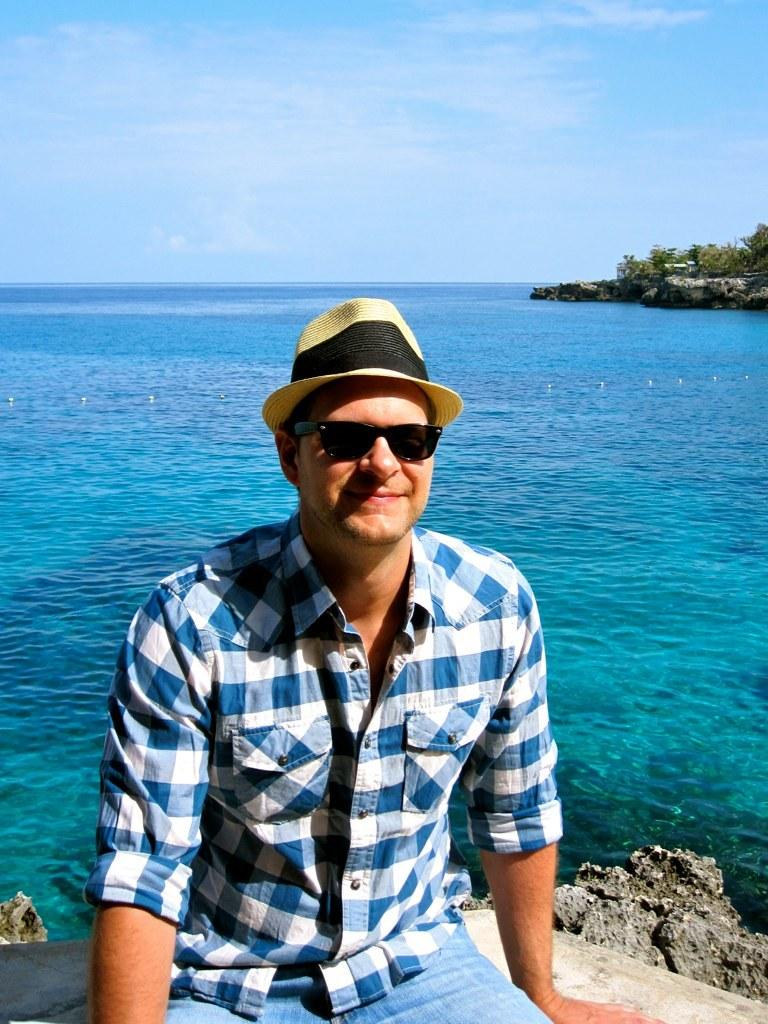What can be seen in the image? There is a person in the image. What is the person wearing? The person is wearing goggles and a hat. What is the person's facial expression? The person is smiling. What is the person's position in the image? The person is sitting on a surface. What can be seen in the background of the image? There is a wall, trees, rocks, water, and the sky visible in the background. What type of insect is the person holding in the image? There is no insect present in the image. 